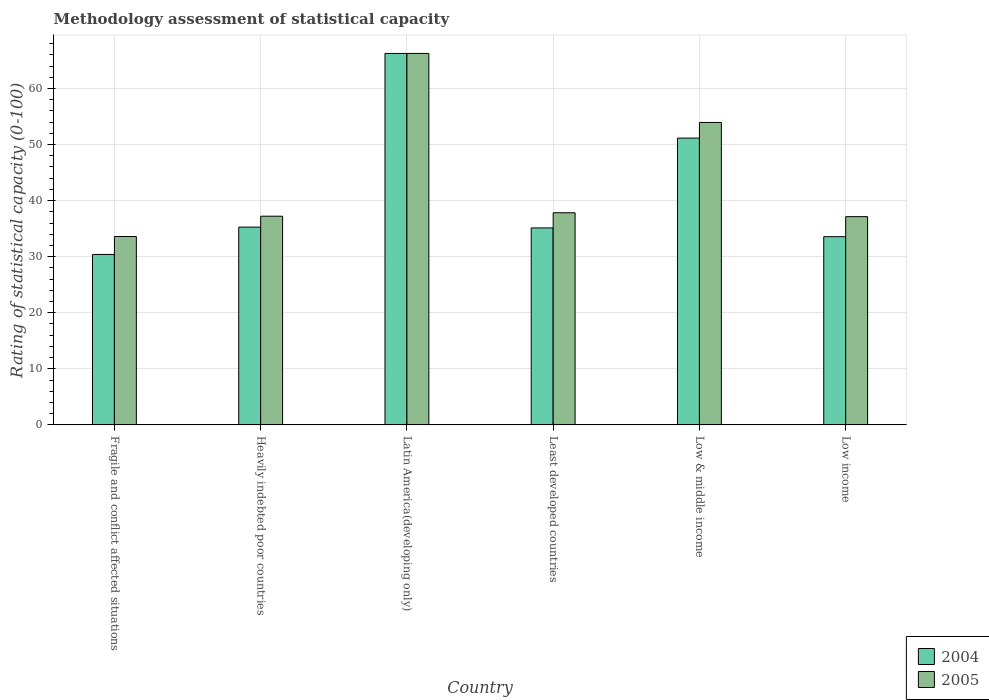How many different coloured bars are there?
Provide a succinct answer. 2. Are the number of bars per tick equal to the number of legend labels?
Ensure brevity in your answer.  Yes. Are the number of bars on each tick of the X-axis equal?
Give a very brief answer. Yes. How many bars are there on the 3rd tick from the left?
Ensure brevity in your answer.  2. How many bars are there on the 3rd tick from the right?
Your answer should be very brief. 2. What is the label of the 2nd group of bars from the left?
Provide a short and direct response. Heavily indebted poor countries. What is the rating of statistical capacity in 2004 in Fragile and conflict affected situations?
Ensure brevity in your answer.  30.4. Across all countries, what is the maximum rating of statistical capacity in 2005?
Make the answer very short. 66.25. Across all countries, what is the minimum rating of statistical capacity in 2005?
Offer a terse response. 33.6. In which country was the rating of statistical capacity in 2004 maximum?
Provide a succinct answer. Latin America(developing only). In which country was the rating of statistical capacity in 2005 minimum?
Your answer should be very brief. Fragile and conflict affected situations. What is the total rating of statistical capacity in 2005 in the graph?
Your response must be concise. 266. What is the difference between the rating of statistical capacity in 2004 in Heavily indebted poor countries and that in Low & middle income?
Provide a succinct answer. -15.88. What is the difference between the rating of statistical capacity in 2004 in Heavily indebted poor countries and the rating of statistical capacity in 2005 in Least developed countries?
Make the answer very short. -2.56. What is the average rating of statistical capacity in 2005 per country?
Offer a very short reply. 44.33. What is the difference between the rating of statistical capacity of/in 2005 and rating of statistical capacity of/in 2004 in Least developed countries?
Your answer should be very brief. 2.7. What is the ratio of the rating of statistical capacity in 2004 in Fragile and conflict affected situations to that in Low income?
Give a very brief answer. 0.91. Is the difference between the rating of statistical capacity in 2005 in Heavily indebted poor countries and Least developed countries greater than the difference between the rating of statistical capacity in 2004 in Heavily indebted poor countries and Least developed countries?
Make the answer very short. No. What is the difference between the highest and the second highest rating of statistical capacity in 2004?
Offer a terse response. -30.97. What is the difference between the highest and the lowest rating of statistical capacity in 2005?
Provide a succinct answer. 32.65. In how many countries, is the rating of statistical capacity in 2005 greater than the average rating of statistical capacity in 2005 taken over all countries?
Give a very brief answer. 2. What does the 2nd bar from the right in Fragile and conflict affected situations represents?
Your answer should be very brief. 2004. Are all the bars in the graph horizontal?
Your answer should be compact. No. What is the difference between two consecutive major ticks on the Y-axis?
Provide a succinct answer. 10. Does the graph contain any zero values?
Provide a succinct answer. No. Where does the legend appear in the graph?
Keep it short and to the point. Bottom right. How many legend labels are there?
Your response must be concise. 2. What is the title of the graph?
Make the answer very short. Methodology assessment of statistical capacity. Does "1966" appear as one of the legend labels in the graph?
Provide a succinct answer. No. What is the label or title of the Y-axis?
Keep it short and to the point. Rating of statistical capacity (0-100). What is the Rating of statistical capacity (0-100) of 2004 in Fragile and conflict affected situations?
Give a very brief answer. 30.4. What is the Rating of statistical capacity (0-100) of 2005 in Fragile and conflict affected situations?
Provide a succinct answer. 33.6. What is the Rating of statistical capacity (0-100) in 2004 in Heavily indebted poor countries?
Make the answer very short. 35.28. What is the Rating of statistical capacity (0-100) in 2005 in Heavily indebted poor countries?
Ensure brevity in your answer.  37.22. What is the Rating of statistical capacity (0-100) in 2004 in Latin America(developing only)?
Ensure brevity in your answer.  66.25. What is the Rating of statistical capacity (0-100) in 2005 in Latin America(developing only)?
Provide a succinct answer. 66.25. What is the Rating of statistical capacity (0-100) in 2004 in Least developed countries?
Make the answer very short. 35.14. What is the Rating of statistical capacity (0-100) of 2005 in Least developed countries?
Ensure brevity in your answer.  37.84. What is the Rating of statistical capacity (0-100) of 2004 in Low & middle income?
Your answer should be very brief. 51.15. What is the Rating of statistical capacity (0-100) of 2005 in Low & middle income?
Provide a short and direct response. 53.94. What is the Rating of statistical capacity (0-100) in 2004 in Low income?
Offer a terse response. 33.57. What is the Rating of statistical capacity (0-100) in 2005 in Low income?
Make the answer very short. 37.14. Across all countries, what is the maximum Rating of statistical capacity (0-100) in 2004?
Offer a very short reply. 66.25. Across all countries, what is the maximum Rating of statistical capacity (0-100) in 2005?
Your response must be concise. 66.25. Across all countries, what is the minimum Rating of statistical capacity (0-100) of 2004?
Give a very brief answer. 30.4. Across all countries, what is the minimum Rating of statistical capacity (0-100) in 2005?
Give a very brief answer. 33.6. What is the total Rating of statistical capacity (0-100) in 2004 in the graph?
Your answer should be compact. 251.79. What is the total Rating of statistical capacity (0-100) in 2005 in the graph?
Keep it short and to the point. 266. What is the difference between the Rating of statistical capacity (0-100) of 2004 in Fragile and conflict affected situations and that in Heavily indebted poor countries?
Your answer should be compact. -4.88. What is the difference between the Rating of statistical capacity (0-100) in 2005 in Fragile and conflict affected situations and that in Heavily indebted poor countries?
Ensure brevity in your answer.  -3.62. What is the difference between the Rating of statistical capacity (0-100) of 2004 in Fragile and conflict affected situations and that in Latin America(developing only)?
Provide a short and direct response. -35.85. What is the difference between the Rating of statistical capacity (0-100) in 2005 in Fragile and conflict affected situations and that in Latin America(developing only)?
Ensure brevity in your answer.  -32.65. What is the difference between the Rating of statistical capacity (0-100) of 2004 in Fragile and conflict affected situations and that in Least developed countries?
Provide a short and direct response. -4.74. What is the difference between the Rating of statistical capacity (0-100) in 2005 in Fragile and conflict affected situations and that in Least developed countries?
Provide a succinct answer. -4.24. What is the difference between the Rating of statistical capacity (0-100) of 2004 in Fragile and conflict affected situations and that in Low & middle income?
Make the answer very short. -20.75. What is the difference between the Rating of statistical capacity (0-100) of 2005 in Fragile and conflict affected situations and that in Low & middle income?
Ensure brevity in your answer.  -20.34. What is the difference between the Rating of statistical capacity (0-100) in 2004 in Fragile and conflict affected situations and that in Low income?
Ensure brevity in your answer.  -3.17. What is the difference between the Rating of statistical capacity (0-100) of 2005 in Fragile and conflict affected situations and that in Low income?
Offer a terse response. -3.54. What is the difference between the Rating of statistical capacity (0-100) of 2004 in Heavily indebted poor countries and that in Latin America(developing only)?
Provide a short and direct response. -30.97. What is the difference between the Rating of statistical capacity (0-100) of 2005 in Heavily indebted poor countries and that in Latin America(developing only)?
Ensure brevity in your answer.  -29.03. What is the difference between the Rating of statistical capacity (0-100) in 2004 in Heavily indebted poor countries and that in Least developed countries?
Offer a very short reply. 0.14. What is the difference between the Rating of statistical capacity (0-100) in 2005 in Heavily indebted poor countries and that in Least developed countries?
Offer a terse response. -0.62. What is the difference between the Rating of statistical capacity (0-100) of 2004 in Heavily indebted poor countries and that in Low & middle income?
Offer a terse response. -15.88. What is the difference between the Rating of statistical capacity (0-100) of 2005 in Heavily indebted poor countries and that in Low & middle income?
Provide a short and direct response. -16.72. What is the difference between the Rating of statistical capacity (0-100) in 2004 in Heavily indebted poor countries and that in Low income?
Your answer should be compact. 1.71. What is the difference between the Rating of statistical capacity (0-100) in 2005 in Heavily indebted poor countries and that in Low income?
Offer a terse response. 0.08. What is the difference between the Rating of statistical capacity (0-100) in 2004 in Latin America(developing only) and that in Least developed countries?
Your answer should be compact. 31.11. What is the difference between the Rating of statistical capacity (0-100) of 2005 in Latin America(developing only) and that in Least developed countries?
Give a very brief answer. 28.41. What is the difference between the Rating of statistical capacity (0-100) in 2004 in Latin America(developing only) and that in Low & middle income?
Offer a very short reply. 15.1. What is the difference between the Rating of statistical capacity (0-100) in 2005 in Latin America(developing only) and that in Low & middle income?
Make the answer very short. 12.31. What is the difference between the Rating of statistical capacity (0-100) of 2004 in Latin America(developing only) and that in Low income?
Ensure brevity in your answer.  32.68. What is the difference between the Rating of statistical capacity (0-100) of 2005 in Latin America(developing only) and that in Low income?
Provide a short and direct response. 29.11. What is the difference between the Rating of statistical capacity (0-100) in 2004 in Least developed countries and that in Low & middle income?
Offer a terse response. -16.02. What is the difference between the Rating of statistical capacity (0-100) of 2005 in Least developed countries and that in Low & middle income?
Provide a succinct answer. -16.1. What is the difference between the Rating of statistical capacity (0-100) of 2004 in Least developed countries and that in Low income?
Your answer should be compact. 1.56. What is the difference between the Rating of statistical capacity (0-100) in 2005 in Least developed countries and that in Low income?
Your answer should be compact. 0.69. What is the difference between the Rating of statistical capacity (0-100) in 2004 in Low & middle income and that in Low income?
Your response must be concise. 17.58. What is the difference between the Rating of statistical capacity (0-100) of 2005 in Low & middle income and that in Low income?
Provide a succinct answer. 16.8. What is the difference between the Rating of statistical capacity (0-100) in 2004 in Fragile and conflict affected situations and the Rating of statistical capacity (0-100) in 2005 in Heavily indebted poor countries?
Ensure brevity in your answer.  -6.82. What is the difference between the Rating of statistical capacity (0-100) of 2004 in Fragile and conflict affected situations and the Rating of statistical capacity (0-100) of 2005 in Latin America(developing only)?
Offer a very short reply. -35.85. What is the difference between the Rating of statistical capacity (0-100) of 2004 in Fragile and conflict affected situations and the Rating of statistical capacity (0-100) of 2005 in Least developed countries?
Your answer should be compact. -7.44. What is the difference between the Rating of statistical capacity (0-100) in 2004 in Fragile and conflict affected situations and the Rating of statistical capacity (0-100) in 2005 in Low & middle income?
Your response must be concise. -23.54. What is the difference between the Rating of statistical capacity (0-100) in 2004 in Fragile and conflict affected situations and the Rating of statistical capacity (0-100) in 2005 in Low income?
Your response must be concise. -6.74. What is the difference between the Rating of statistical capacity (0-100) in 2004 in Heavily indebted poor countries and the Rating of statistical capacity (0-100) in 2005 in Latin America(developing only)?
Your response must be concise. -30.97. What is the difference between the Rating of statistical capacity (0-100) of 2004 in Heavily indebted poor countries and the Rating of statistical capacity (0-100) of 2005 in Least developed countries?
Give a very brief answer. -2.56. What is the difference between the Rating of statistical capacity (0-100) in 2004 in Heavily indebted poor countries and the Rating of statistical capacity (0-100) in 2005 in Low & middle income?
Offer a terse response. -18.66. What is the difference between the Rating of statistical capacity (0-100) in 2004 in Heavily indebted poor countries and the Rating of statistical capacity (0-100) in 2005 in Low income?
Keep it short and to the point. -1.87. What is the difference between the Rating of statistical capacity (0-100) of 2004 in Latin America(developing only) and the Rating of statistical capacity (0-100) of 2005 in Least developed countries?
Your response must be concise. 28.41. What is the difference between the Rating of statistical capacity (0-100) in 2004 in Latin America(developing only) and the Rating of statistical capacity (0-100) in 2005 in Low & middle income?
Offer a very short reply. 12.31. What is the difference between the Rating of statistical capacity (0-100) of 2004 in Latin America(developing only) and the Rating of statistical capacity (0-100) of 2005 in Low income?
Offer a terse response. 29.11. What is the difference between the Rating of statistical capacity (0-100) of 2004 in Least developed countries and the Rating of statistical capacity (0-100) of 2005 in Low & middle income?
Make the answer very short. -18.81. What is the difference between the Rating of statistical capacity (0-100) in 2004 in Least developed countries and the Rating of statistical capacity (0-100) in 2005 in Low income?
Keep it short and to the point. -2.01. What is the difference between the Rating of statistical capacity (0-100) of 2004 in Low & middle income and the Rating of statistical capacity (0-100) of 2005 in Low income?
Provide a short and direct response. 14.01. What is the average Rating of statistical capacity (0-100) of 2004 per country?
Your answer should be compact. 41.96. What is the average Rating of statistical capacity (0-100) in 2005 per country?
Provide a succinct answer. 44.33. What is the difference between the Rating of statistical capacity (0-100) in 2004 and Rating of statistical capacity (0-100) in 2005 in Fragile and conflict affected situations?
Make the answer very short. -3.2. What is the difference between the Rating of statistical capacity (0-100) of 2004 and Rating of statistical capacity (0-100) of 2005 in Heavily indebted poor countries?
Make the answer very short. -1.94. What is the difference between the Rating of statistical capacity (0-100) in 2004 and Rating of statistical capacity (0-100) in 2005 in Latin America(developing only)?
Provide a short and direct response. 0. What is the difference between the Rating of statistical capacity (0-100) in 2004 and Rating of statistical capacity (0-100) in 2005 in Least developed countries?
Your response must be concise. -2.7. What is the difference between the Rating of statistical capacity (0-100) of 2004 and Rating of statistical capacity (0-100) of 2005 in Low & middle income?
Your response must be concise. -2.79. What is the difference between the Rating of statistical capacity (0-100) of 2004 and Rating of statistical capacity (0-100) of 2005 in Low income?
Your response must be concise. -3.57. What is the ratio of the Rating of statistical capacity (0-100) of 2004 in Fragile and conflict affected situations to that in Heavily indebted poor countries?
Offer a very short reply. 0.86. What is the ratio of the Rating of statistical capacity (0-100) of 2005 in Fragile and conflict affected situations to that in Heavily indebted poor countries?
Provide a short and direct response. 0.9. What is the ratio of the Rating of statistical capacity (0-100) of 2004 in Fragile and conflict affected situations to that in Latin America(developing only)?
Provide a short and direct response. 0.46. What is the ratio of the Rating of statistical capacity (0-100) in 2005 in Fragile and conflict affected situations to that in Latin America(developing only)?
Make the answer very short. 0.51. What is the ratio of the Rating of statistical capacity (0-100) in 2004 in Fragile and conflict affected situations to that in Least developed countries?
Provide a short and direct response. 0.87. What is the ratio of the Rating of statistical capacity (0-100) in 2005 in Fragile and conflict affected situations to that in Least developed countries?
Give a very brief answer. 0.89. What is the ratio of the Rating of statistical capacity (0-100) in 2004 in Fragile and conflict affected situations to that in Low & middle income?
Your answer should be very brief. 0.59. What is the ratio of the Rating of statistical capacity (0-100) of 2005 in Fragile and conflict affected situations to that in Low & middle income?
Make the answer very short. 0.62. What is the ratio of the Rating of statistical capacity (0-100) of 2004 in Fragile and conflict affected situations to that in Low income?
Provide a short and direct response. 0.91. What is the ratio of the Rating of statistical capacity (0-100) of 2005 in Fragile and conflict affected situations to that in Low income?
Offer a very short reply. 0.9. What is the ratio of the Rating of statistical capacity (0-100) in 2004 in Heavily indebted poor countries to that in Latin America(developing only)?
Ensure brevity in your answer.  0.53. What is the ratio of the Rating of statistical capacity (0-100) in 2005 in Heavily indebted poor countries to that in Latin America(developing only)?
Make the answer very short. 0.56. What is the ratio of the Rating of statistical capacity (0-100) of 2004 in Heavily indebted poor countries to that in Least developed countries?
Offer a terse response. 1. What is the ratio of the Rating of statistical capacity (0-100) in 2005 in Heavily indebted poor countries to that in Least developed countries?
Keep it short and to the point. 0.98. What is the ratio of the Rating of statistical capacity (0-100) in 2004 in Heavily indebted poor countries to that in Low & middle income?
Ensure brevity in your answer.  0.69. What is the ratio of the Rating of statistical capacity (0-100) in 2005 in Heavily indebted poor countries to that in Low & middle income?
Give a very brief answer. 0.69. What is the ratio of the Rating of statistical capacity (0-100) of 2004 in Heavily indebted poor countries to that in Low income?
Your answer should be very brief. 1.05. What is the ratio of the Rating of statistical capacity (0-100) in 2005 in Heavily indebted poor countries to that in Low income?
Offer a terse response. 1. What is the ratio of the Rating of statistical capacity (0-100) of 2004 in Latin America(developing only) to that in Least developed countries?
Offer a terse response. 1.89. What is the ratio of the Rating of statistical capacity (0-100) in 2005 in Latin America(developing only) to that in Least developed countries?
Your response must be concise. 1.75. What is the ratio of the Rating of statistical capacity (0-100) in 2004 in Latin America(developing only) to that in Low & middle income?
Your answer should be very brief. 1.3. What is the ratio of the Rating of statistical capacity (0-100) of 2005 in Latin America(developing only) to that in Low & middle income?
Offer a terse response. 1.23. What is the ratio of the Rating of statistical capacity (0-100) of 2004 in Latin America(developing only) to that in Low income?
Give a very brief answer. 1.97. What is the ratio of the Rating of statistical capacity (0-100) of 2005 in Latin America(developing only) to that in Low income?
Your answer should be compact. 1.78. What is the ratio of the Rating of statistical capacity (0-100) in 2004 in Least developed countries to that in Low & middle income?
Provide a succinct answer. 0.69. What is the ratio of the Rating of statistical capacity (0-100) of 2005 in Least developed countries to that in Low & middle income?
Offer a very short reply. 0.7. What is the ratio of the Rating of statistical capacity (0-100) in 2004 in Least developed countries to that in Low income?
Keep it short and to the point. 1.05. What is the ratio of the Rating of statistical capacity (0-100) in 2005 in Least developed countries to that in Low income?
Provide a succinct answer. 1.02. What is the ratio of the Rating of statistical capacity (0-100) in 2004 in Low & middle income to that in Low income?
Offer a terse response. 1.52. What is the ratio of the Rating of statistical capacity (0-100) in 2005 in Low & middle income to that in Low income?
Keep it short and to the point. 1.45. What is the difference between the highest and the second highest Rating of statistical capacity (0-100) in 2004?
Give a very brief answer. 15.1. What is the difference between the highest and the second highest Rating of statistical capacity (0-100) in 2005?
Provide a succinct answer. 12.31. What is the difference between the highest and the lowest Rating of statistical capacity (0-100) in 2004?
Keep it short and to the point. 35.85. What is the difference between the highest and the lowest Rating of statistical capacity (0-100) of 2005?
Make the answer very short. 32.65. 